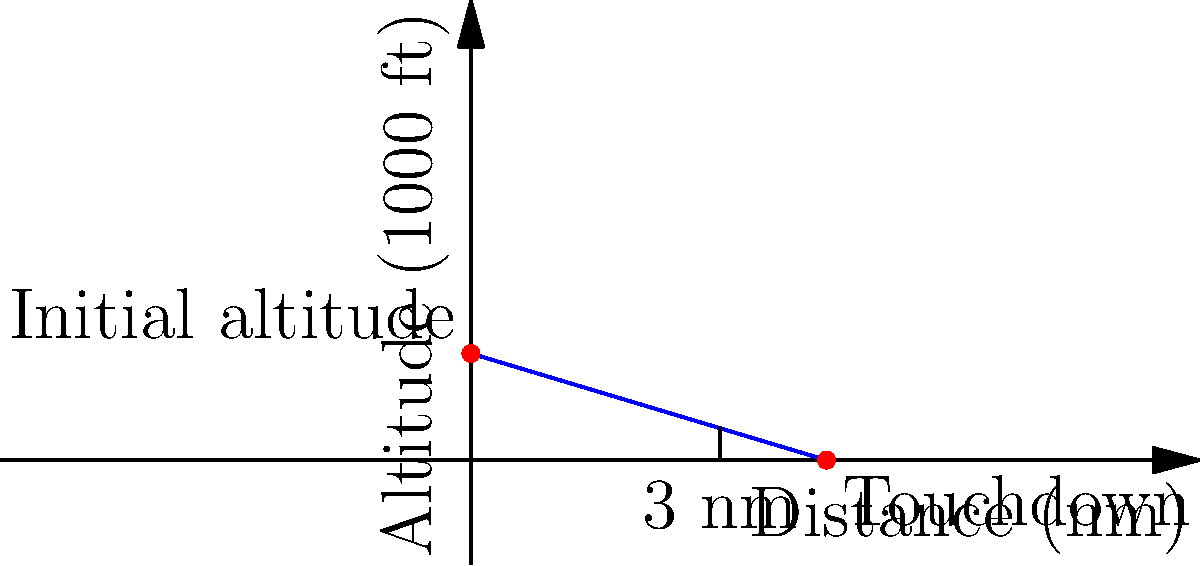As a newly licensed pilot approaching an airport, you observe the glide slope indicator diagram shown above. The diagram represents a 3-degree glide path for a 10 nautical mile (nm) final approach, starting at 3,000 feet altitude. If you are currently at 2,100 feet and 7 nm from touchdown, what should your descent rate be in feet per minute (fpm) to intercept and maintain the proper glide path? Assume your groundspeed is 120 knots. Let's approach this step-by-step:

1) First, we need to determine the ideal altitude at 7 nm from touchdown:
   
   The glide slope is linear, so we can use the equation of a line:
   $y = mx + b$, where $m$ is the slope and $b$ is the y-intercept.

   $m = \frac{-3000 \text{ ft}}{10 \text{ nm}} = -300 \text{ ft/nm}$
   $b = 3000 \text{ ft}$ (initial altitude)

   At 7 nm: $y = -300 * 7 + 3000 = 900 \text{ ft}$

2) Calculate the altitude difference:
   $2100 \text{ ft} - 900 \text{ ft} = 1200 \text{ ft}$
   This is how much altitude you need to lose.

3) Calculate the time to cover 7 nm at 120 knots:
   $\frac{7 \text{ nm}}{120 \text{ knots}} = 0.0583 \text{ hours} = 3.5 \text{ minutes}$

4) Calculate the required descent rate:
   $\frac{1200 \text{ ft}}{3.5 \text{ min}} = 342.86 \text{ ft/min}$

5) Round to the nearest 10 fpm as is common in aviation:
   $340 \text{ fpm}$

This descent rate will bring you to the proper glide path at the 7 nm point, after which you should maintain a 300 fpm descent to stay on the 3-degree glide path.
Answer: 340 fpm 